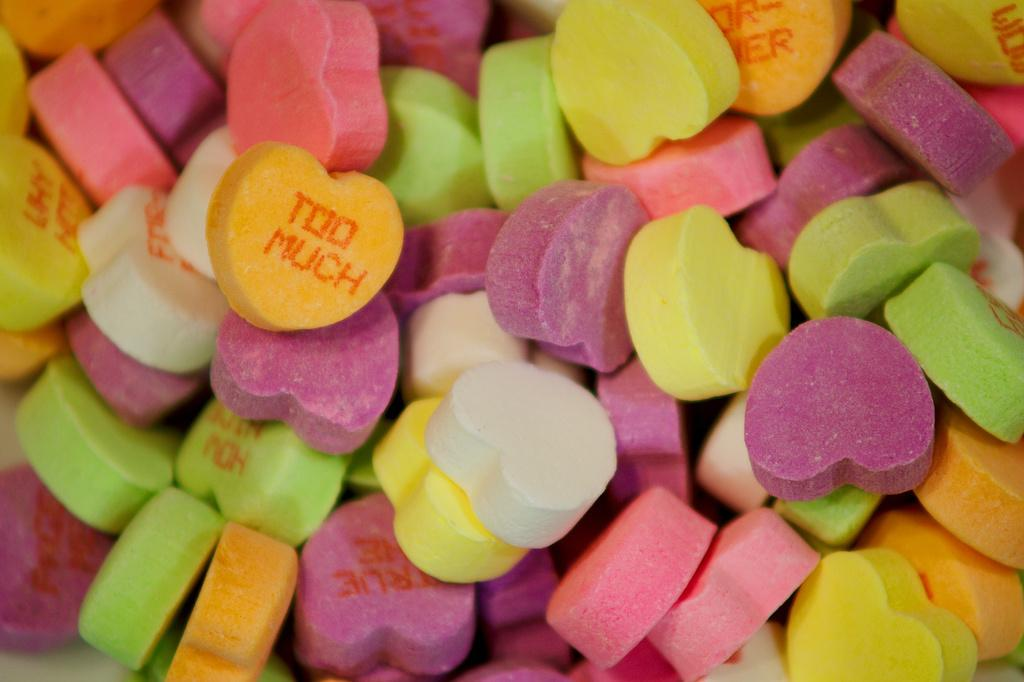What type of candies are in the image? There are colorful candies in the image. How are the candies arranged in the image? The candies are in a heart shape. What type of pet can be seen playing with the candies in the image? There is no pet present in the image; it only features colorful candies arranged in a heart shape. 